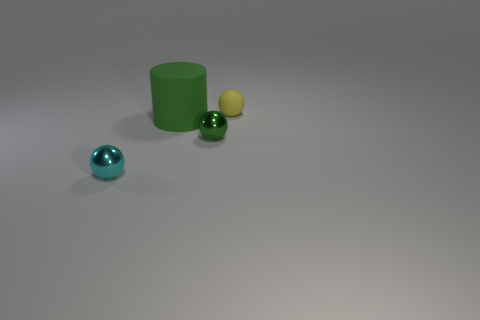What number of tiny yellow rubber balls are there?
Provide a short and direct response. 1. Do the large green cylinder and the small cyan sphere have the same material?
Your answer should be compact. No. What shape is the small shiny object that is right of the metallic thing that is left of the green object that is in front of the green matte thing?
Provide a short and direct response. Sphere. Does the yellow sphere behind the small cyan metallic thing have the same material as the green thing right of the big object?
Your answer should be compact. No. What is the tiny green ball made of?
Your response must be concise. Metal. How many other large objects are the same shape as the green matte object?
Offer a very short reply. 0. There is a ball that is the same color as the big rubber thing; what material is it?
Provide a short and direct response. Metal. Is there anything else that has the same shape as the tiny rubber object?
Keep it short and to the point. Yes. There is a metallic sphere in front of the small metal thing that is behind the tiny shiny ball on the left side of the rubber cylinder; what is its color?
Provide a short and direct response. Cyan. What number of tiny objects are cylinders or cyan metal balls?
Your response must be concise. 1. 